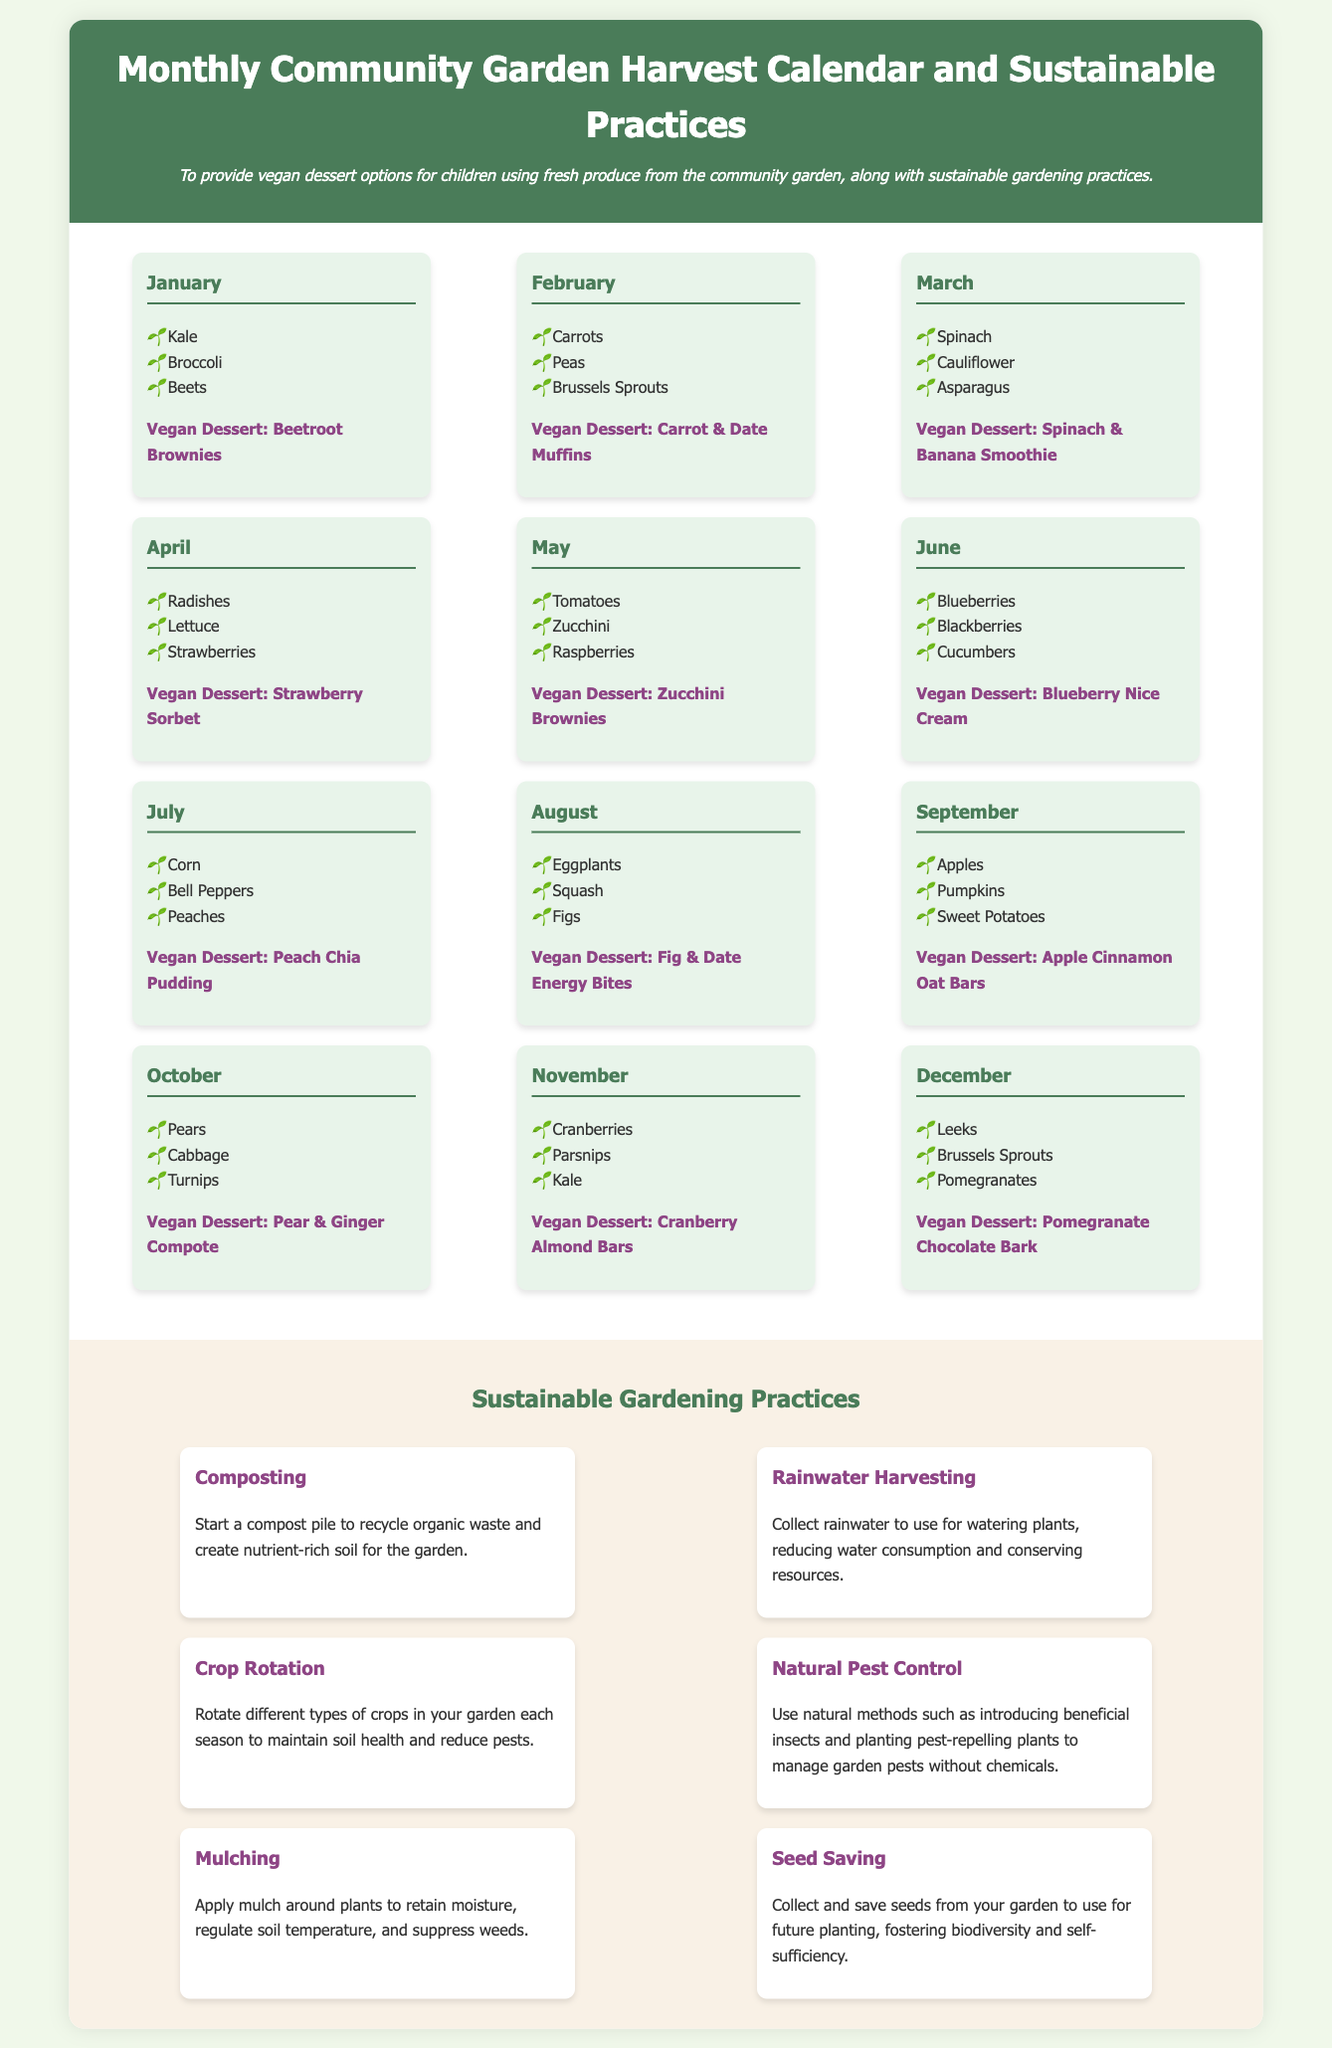What vegan dessert can be made with kale? The document states that the vegan dessert for January using kale is Beetroot Brownies.
Answer: Beetroot Brownies How many months feature strawberries in the dessert options? The document mentions that strawberries are featured in the dessert options for April which is one month.
Answer: 1 What is a sustainable gardening practice mentioned in the document? The document lists several sustainable gardening practices, one of which is Composting.
Answer: Composting Which month includes pears in the harvest calendar? The document indicates that pears are included in the month of October.
Answer: October What vegan dessert can be made with apples? According to the document, the vegan dessert that can be made with apples is Apple Cinnamon Oat Bars.
Answer: Apple Cinnamon Oat Bars What is the total number of produce items listed for June? The document lists three produce items for June: Blueberries, Blackberries, and Cucumbers.
Answer: 3 Which dessert is suggested for the month of August? The document specifies that the vegan dessert for August is Fig & Date Energy Bites.
Answer: Fig & Date Energy Bites What environmental benefit is associated with rainwater harvesting? The document explains that rainwater harvesting reduces water consumption and conserves resources.
Answer: Reduces water consumption 